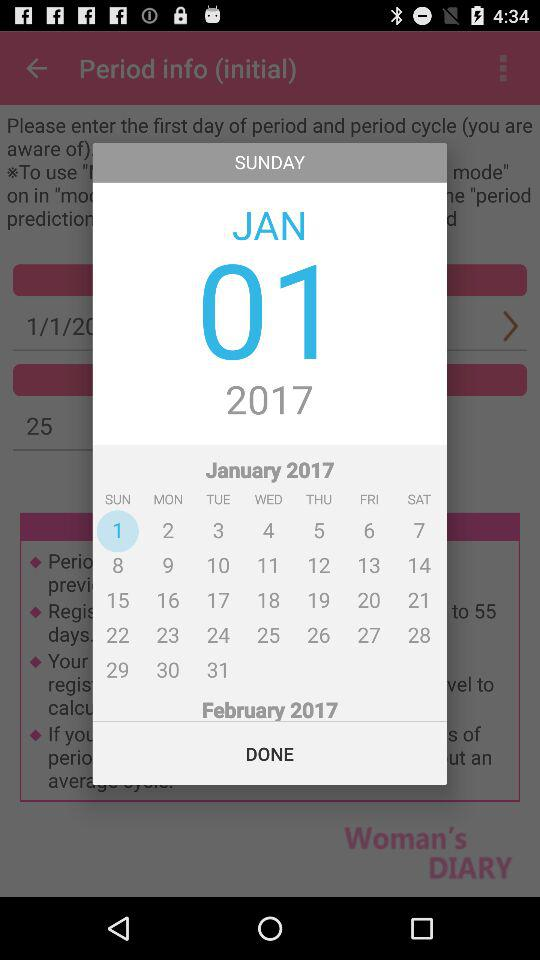What day is January 17th? The day is Tuesday. 